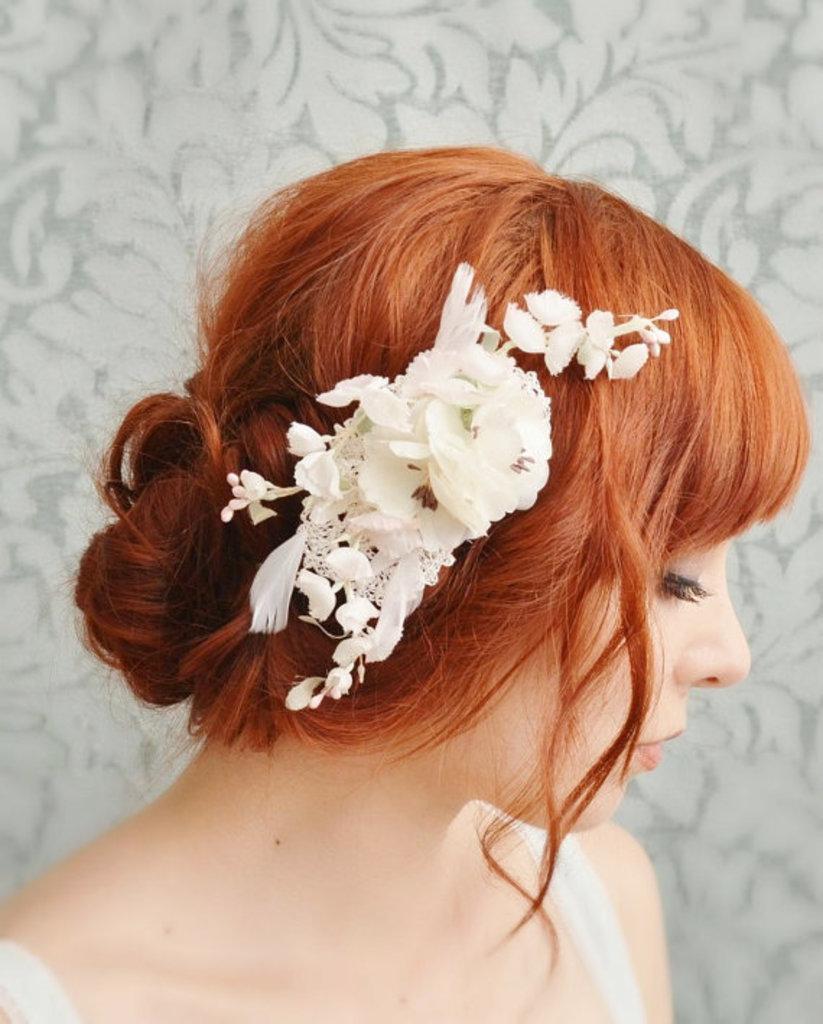How would you summarize this image in a sentence or two? In this image we can see a woman who is having flowers in her hair. In the background, we can see a wall with a different design. 